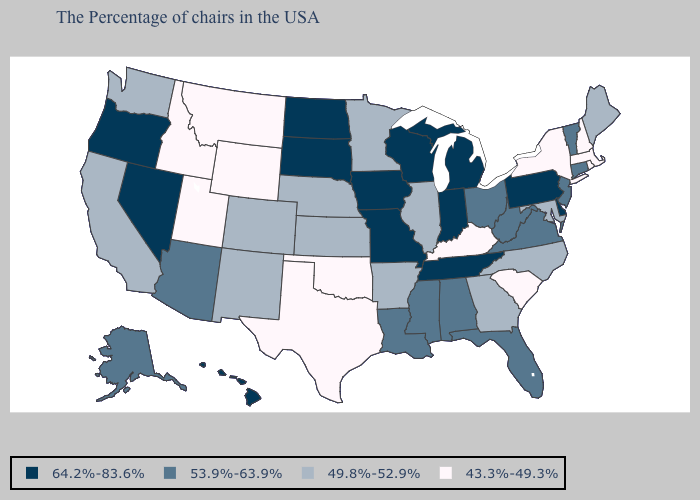What is the lowest value in the Northeast?
Quick response, please. 43.3%-49.3%. Name the states that have a value in the range 64.2%-83.6%?
Write a very short answer. Delaware, Pennsylvania, Michigan, Indiana, Tennessee, Wisconsin, Missouri, Iowa, South Dakota, North Dakota, Nevada, Oregon, Hawaii. What is the value of Rhode Island?
Keep it brief. 43.3%-49.3%. Name the states that have a value in the range 53.9%-63.9%?
Short answer required. Vermont, Connecticut, New Jersey, Virginia, West Virginia, Ohio, Florida, Alabama, Mississippi, Louisiana, Arizona, Alaska. What is the highest value in the West ?
Quick response, please. 64.2%-83.6%. What is the value of Maryland?
Be succinct. 49.8%-52.9%. What is the value of Virginia?
Answer briefly. 53.9%-63.9%. What is the lowest value in states that border North Carolina?
Give a very brief answer. 43.3%-49.3%. Name the states that have a value in the range 53.9%-63.9%?
Keep it brief. Vermont, Connecticut, New Jersey, Virginia, West Virginia, Ohio, Florida, Alabama, Mississippi, Louisiana, Arizona, Alaska. Does the map have missing data?
Give a very brief answer. No. What is the highest value in states that border Iowa?
Quick response, please. 64.2%-83.6%. How many symbols are there in the legend?
Concise answer only. 4. Name the states that have a value in the range 43.3%-49.3%?
Answer briefly. Massachusetts, Rhode Island, New Hampshire, New York, South Carolina, Kentucky, Oklahoma, Texas, Wyoming, Utah, Montana, Idaho. What is the value of Maine?
Be succinct. 49.8%-52.9%. 